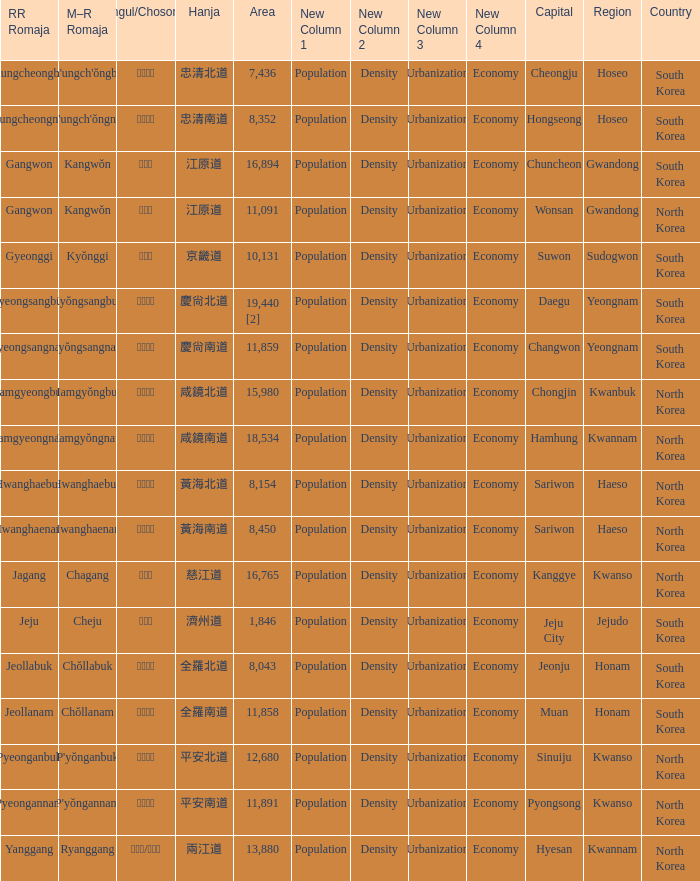Which country has a city with a Hanja of 平安北道? North Korea. 